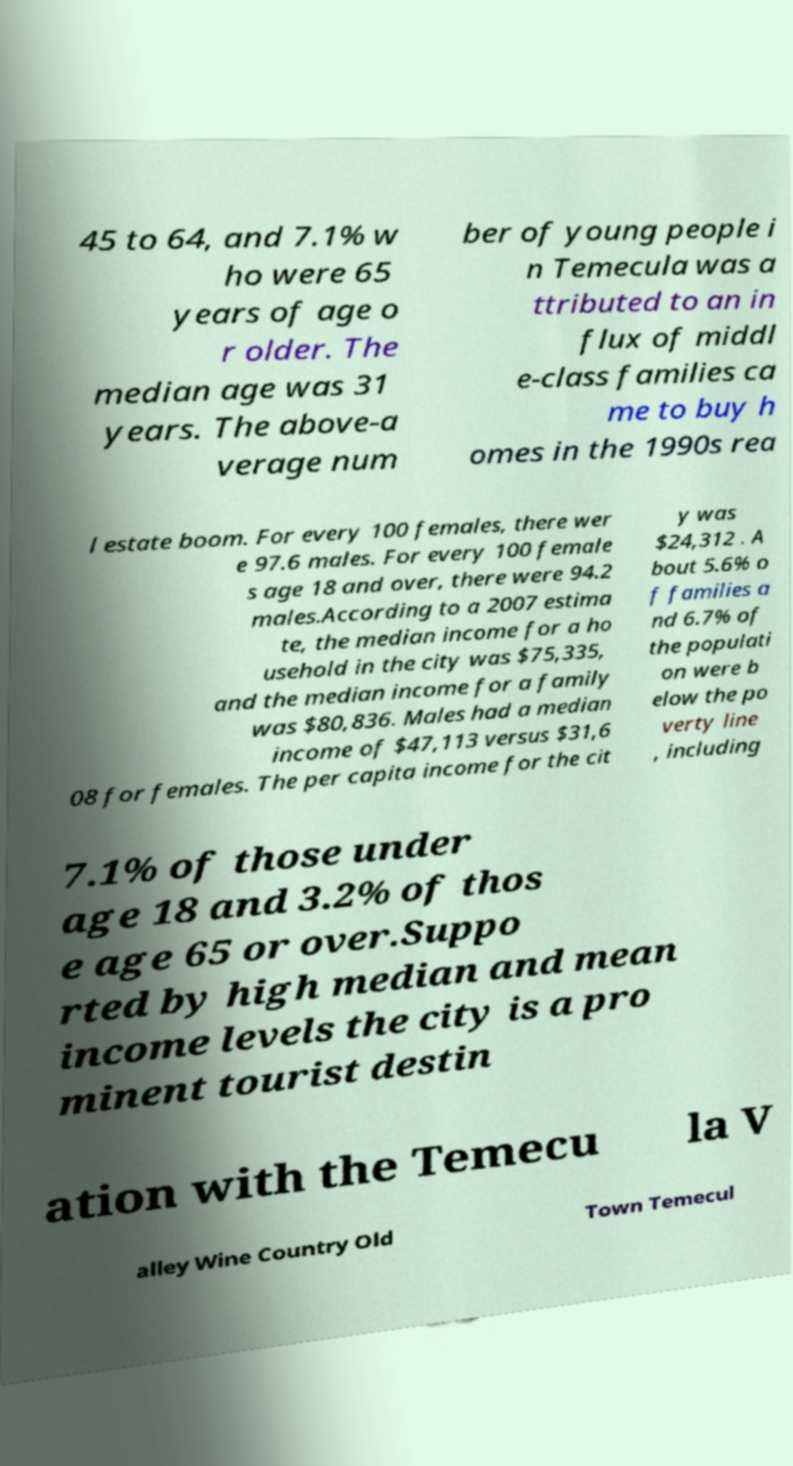What messages or text are displayed in this image? I need them in a readable, typed format. 45 to 64, and 7.1% w ho were 65 years of age o r older. The median age was 31 years. The above-a verage num ber of young people i n Temecula was a ttributed to an in flux of middl e-class families ca me to buy h omes in the 1990s rea l estate boom. For every 100 females, there wer e 97.6 males. For every 100 female s age 18 and over, there were 94.2 males.According to a 2007 estima te, the median income for a ho usehold in the city was $75,335, and the median income for a family was $80,836. Males had a median income of $47,113 versus $31,6 08 for females. The per capita income for the cit y was $24,312 . A bout 5.6% o f families a nd 6.7% of the populati on were b elow the po verty line , including 7.1% of those under age 18 and 3.2% of thos e age 65 or over.Suppo rted by high median and mean income levels the city is a pro minent tourist destin ation with the Temecu la V alley Wine Country Old Town Temecul 